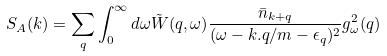Convert formula to latex. <formula><loc_0><loc_0><loc_500><loc_500>S _ { A } ( { k } ) = \sum _ { q } \int _ { 0 } ^ { \infty } d \omega { \tilde { W } } ( { q } , \omega ) \frac { { \bar { n } } _ { k + q } } { ( \omega - { k . q } / m - \epsilon _ { q } ) ^ { 2 } } g _ { \omega } ^ { 2 } ( { q } )</formula> 